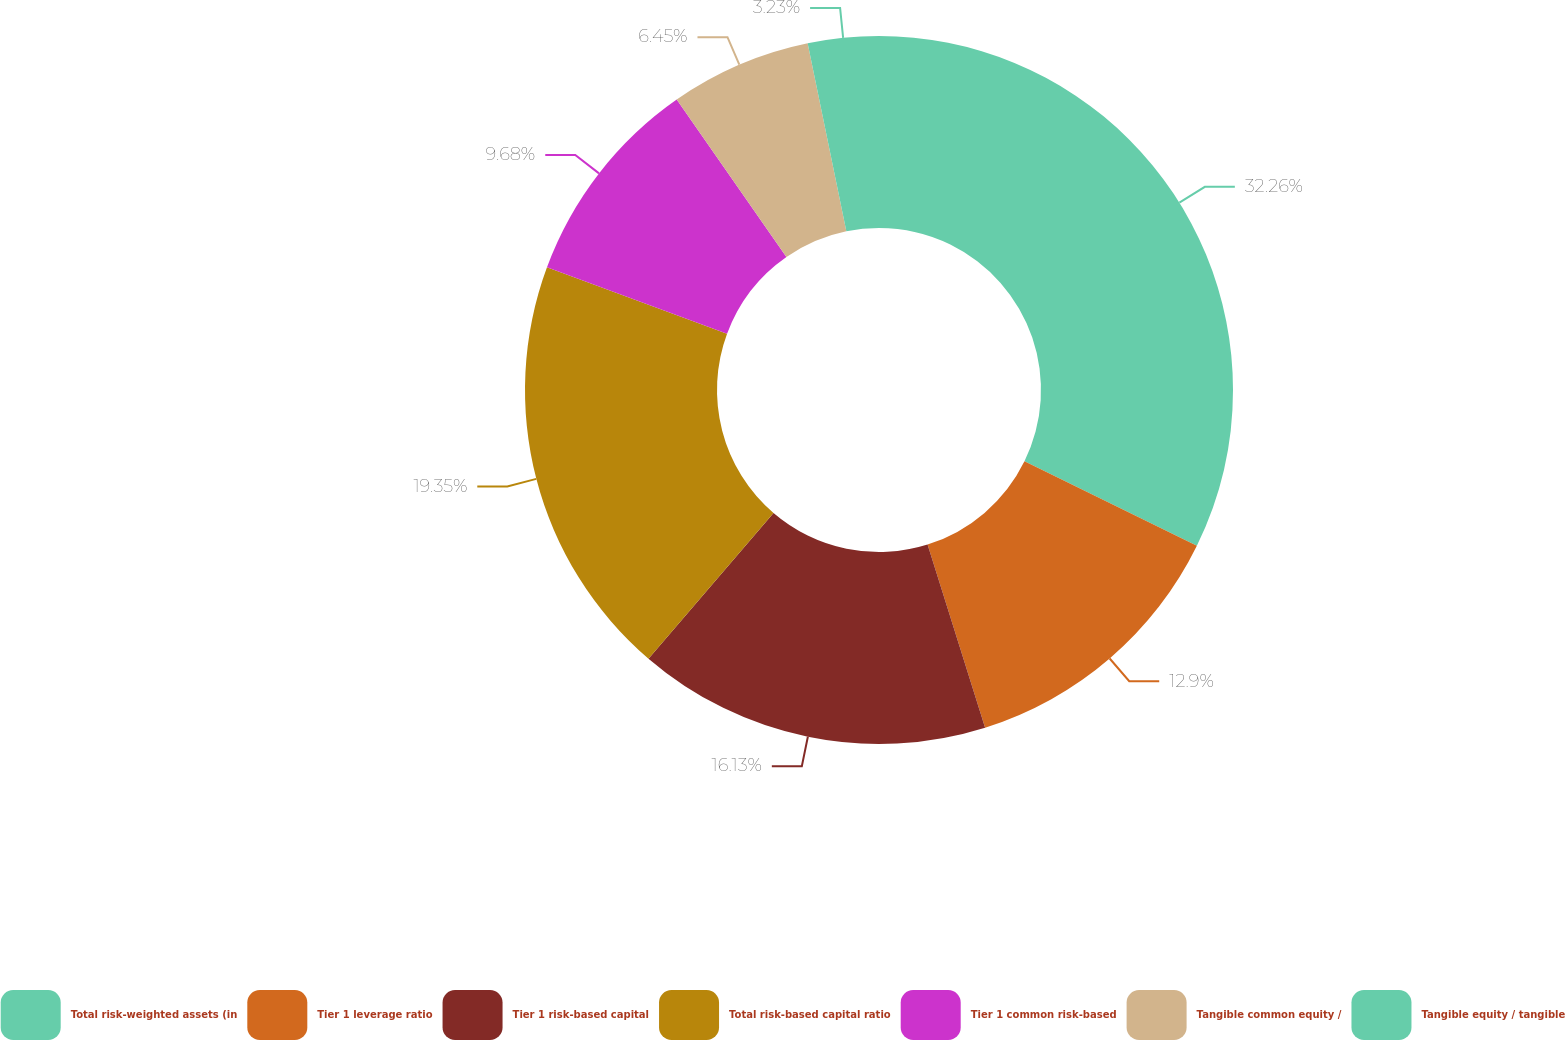<chart> <loc_0><loc_0><loc_500><loc_500><pie_chart><fcel>Total risk-weighted assets (in<fcel>Tier 1 leverage ratio<fcel>Tier 1 risk-based capital<fcel>Total risk-based capital ratio<fcel>Tier 1 common risk-based<fcel>Tangible common equity /<fcel>Tangible equity / tangible<nl><fcel>32.25%<fcel>12.9%<fcel>16.13%<fcel>19.35%<fcel>9.68%<fcel>6.45%<fcel>3.23%<nl></chart> 